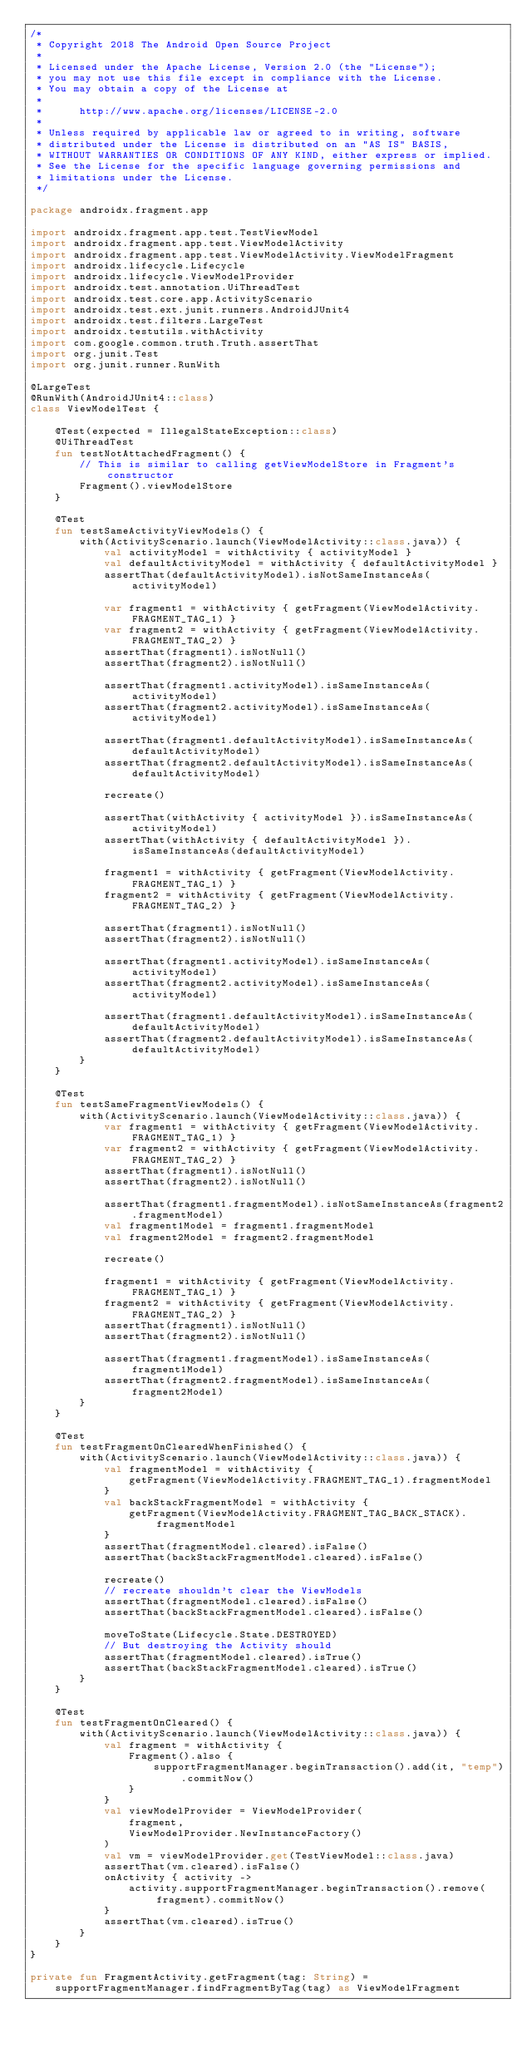<code> <loc_0><loc_0><loc_500><loc_500><_Kotlin_>/*
 * Copyright 2018 The Android Open Source Project
 *
 * Licensed under the Apache License, Version 2.0 (the "License");
 * you may not use this file except in compliance with the License.
 * You may obtain a copy of the License at
 *
 *      http://www.apache.org/licenses/LICENSE-2.0
 *
 * Unless required by applicable law or agreed to in writing, software
 * distributed under the License is distributed on an "AS IS" BASIS,
 * WITHOUT WARRANTIES OR CONDITIONS OF ANY KIND, either express or implied.
 * See the License for the specific language governing permissions and
 * limitations under the License.
 */

package androidx.fragment.app

import androidx.fragment.app.test.TestViewModel
import androidx.fragment.app.test.ViewModelActivity
import androidx.fragment.app.test.ViewModelActivity.ViewModelFragment
import androidx.lifecycle.Lifecycle
import androidx.lifecycle.ViewModelProvider
import androidx.test.annotation.UiThreadTest
import androidx.test.core.app.ActivityScenario
import androidx.test.ext.junit.runners.AndroidJUnit4
import androidx.test.filters.LargeTest
import androidx.testutils.withActivity
import com.google.common.truth.Truth.assertThat
import org.junit.Test
import org.junit.runner.RunWith

@LargeTest
@RunWith(AndroidJUnit4::class)
class ViewModelTest {

    @Test(expected = IllegalStateException::class)
    @UiThreadTest
    fun testNotAttachedFragment() {
        // This is similar to calling getViewModelStore in Fragment's constructor
        Fragment().viewModelStore
    }

    @Test
    fun testSameActivityViewModels() {
        with(ActivityScenario.launch(ViewModelActivity::class.java)) {
            val activityModel = withActivity { activityModel }
            val defaultActivityModel = withActivity { defaultActivityModel }
            assertThat(defaultActivityModel).isNotSameInstanceAs(activityModel)

            var fragment1 = withActivity { getFragment(ViewModelActivity.FRAGMENT_TAG_1) }
            var fragment2 = withActivity { getFragment(ViewModelActivity.FRAGMENT_TAG_2) }
            assertThat(fragment1).isNotNull()
            assertThat(fragment2).isNotNull()

            assertThat(fragment1.activityModel).isSameInstanceAs(activityModel)
            assertThat(fragment2.activityModel).isSameInstanceAs(activityModel)

            assertThat(fragment1.defaultActivityModel).isSameInstanceAs(defaultActivityModel)
            assertThat(fragment2.defaultActivityModel).isSameInstanceAs(defaultActivityModel)

            recreate()

            assertThat(withActivity { activityModel }).isSameInstanceAs(activityModel)
            assertThat(withActivity { defaultActivityModel }).isSameInstanceAs(defaultActivityModel)

            fragment1 = withActivity { getFragment(ViewModelActivity.FRAGMENT_TAG_1) }
            fragment2 = withActivity { getFragment(ViewModelActivity.FRAGMENT_TAG_2) }

            assertThat(fragment1).isNotNull()
            assertThat(fragment2).isNotNull()

            assertThat(fragment1.activityModel).isSameInstanceAs(activityModel)
            assertThat(fragment2.activityModel).isSameInstanceAs(activityModel)

            assertThat(fragment1.defaultActivityModel).isSameInstanceAs(defaultActivityModel)
            assertThat(fragment2.defaultActivityModel).isSameInstanceAs(defaultActivityModel)
        }
    }

    @Test
    fun testSameFragmentViewModels() {
        with(ActivityScenario.launch(ViewModelActivity::class.java)) {
            var fragment1 = withActivity { getFragment(ViewModelActivity.FRAGMENT_TAG_1) }
            var fragment2 = withActivity { getFragment(ViewModelActivity.FRAGMENT_TAG_2) }
            assertThat(fragment1).isNotNull()
            assertThat(fragment2).isNotNull()

            assertThat(fragment1.fragmentModel).isNotSameInstanceAs(fragment2.fragmentModel)
            val fragment1Model = fragment1.fragmentModel
            val fragment2Model = fragment2.fragmentModel

            recreate()

            fragment1 = withActivity { getFragment(ViewModelActivity.FRAGMENT_TAG_1) }
            fragment2 = withActivity { getFragment(ViewModelActivity.FRAGMENT_TAG_2) }
            assertThat(fragment1).isNotNull()
            assertThat(fragment2).isNotNull()

            assertThat(fragment1.fragmentModel).isSameInstanceAs(fragment1Model)
            assertThat(fragment2.fragmentModel).isSameInstanceAs(fragment2Model)
        }
    }

    @Test
    fun testFragmentOnClearedWhenFinished() {
        with(ActivityScenario.launch(ViewModelActivity::class.java)) {
            val fragmentModel = withActivity {
                getFragment(ViewModelActivity.FRAGMENT_TAG_1).fragmentModel
            }
            val backStackFragmentModel = withActivity {
                getFragment(ViewModelActivity.FRAGMENT_TAG_BACK_STACK).fragmentModel
            }
            assertThat(fragmentModel.cleared).isFalse()
            assertThat(backStackFragmentModel.cleared).isFalse()

            recreate()
            // recreate shouldn't clear the ViewModels
            assertThat(fragmentModel.cleared).isFalse()
            assertThat(backStackFragmentModel.cleared).isFalse()

            moveToState(Lifecycle.State.DESTROYED)
            // But destroying the Activity should
            assertThat(fragmentModel.cleared).isTrue()
            assertThat(backStackFragmentModel.cleared).isTrue()
        }
    }

    @Test
    fun testFragmentOnCleared() {
        with(ActivityScenario.launch(ViewModelActivity::class.java)) {
            val fragment = withActivity {
                Fragment().also {
                    supportFragmentManager.beginTransaction().add(it, "temp").commitNow()
                }
            }
            val viewModelProvider = ViewModelProvider(
                fragment,
                ViewModelProvider.NewInstanceFactory()
            )
            val vm = viewModelProvider.get(TestViewModel::class.java)
            assertThat(vm.cleared).isFalse()
            onActivity { activity ->
                activity.supportFragmentManager.beginTransaction().remove(fragment).commitNow()
            }
            assertThat(vm.cleared).isTrue()
        }
    }
}

private fun FragmentActivity.getFragment(tag: String) =
    supportFragmentManager.findFragmentByTag(tag) as ViewModelFragment
</code> 